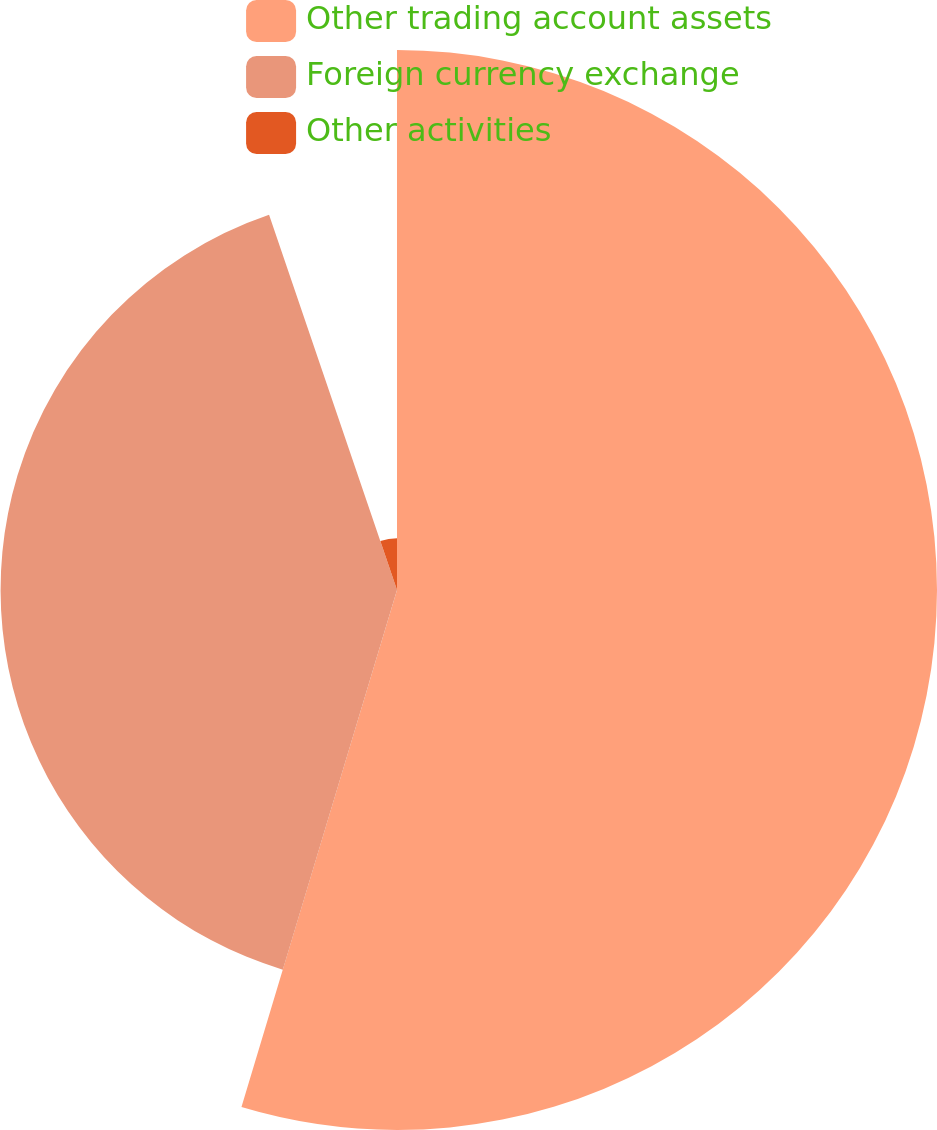Convert chart. <chart><loc_0><loc_0><loc_500><loc_500><pie_chart><fcel>Other trading account assets<fcel>Foreign currency exchange<fcel>Other activities<nl><fcel>54.65%<fcel>40.12%<fcel>5.23%<nl></chart> 